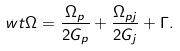<formula> <loc_0><loc_0><loc_500><loc_500>\ w t \Omega = \frac { \Omega _ { p } } { 2 G _ { p } } + \frac { \Omega _ { p j } } { 2 G _ { j } } + \Gamma .</formula> 